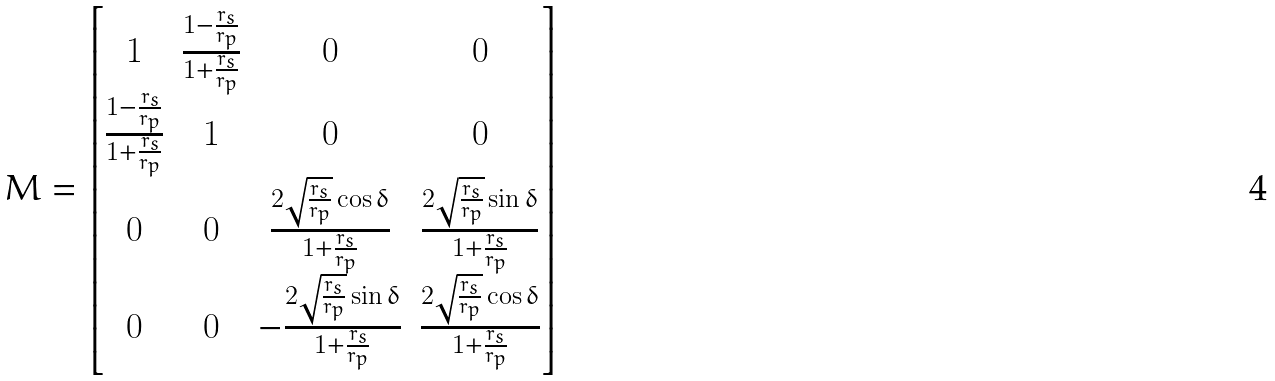Convert formula to latex. <formula><loc_0><loc_0><loc_500><loc_500>M = \begin{bmatrix} 1 & \frac { 1 - \frac { r _ { s } } { r _ { p } } } { 1 + \frac { r _ { s } } { r _ { p } } } & 0 & 0 \\ \frac { 1 - \frac { r _ { s } } { r _ { p } } } { 1 + \frac { r _ { s } } { r _ { p } } } & 1 & 0 & 0 \\ 0 & 0 & \frac { 2 \sqrt { \frac { r _ { s } } { r _ { p } } } \cos \delta } { { 1 + \frac { r _ { s } } { r _ { p } } } } & \frac { 2 \sqrt { \frac { r _ { s } } { r _ { p } } } \sin \delta } { { 1 + \frac { r _ { s } } { r _ { p } } } } \\ 0 & 0 & - \frac { 2 \sqrt { \frac { r _ { s } } { r _ { p } } } \sin \delta } { { 1 + \frac { r _ { s } } { r _ { p } } } } & \frac { 2 \sqrt { \frac { r _ { s } } { r _ { p } } } \cos \delta } { { 1 + \frac { r _ { s } } { r _ { p } } } } \end{bmatrix}</formula> 